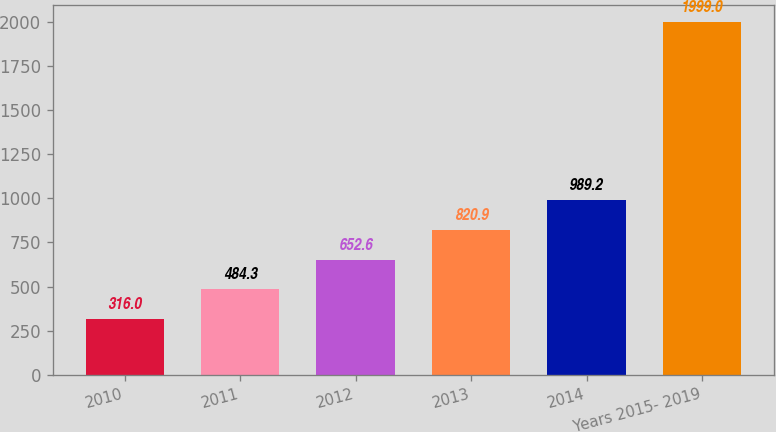<chart> <loc_0><loc_0><loc_500><loc_500><bar_chart><fcel>2010<fcel>2011<fcel>2012<fcel>2013<fcel>2014<fcel>Years 2015- 2019<nl><fcel>316<fcel>484.3<fcel>652.6<fcel>820.9<fcel>989.2<fcel>1999<nl></chart> 